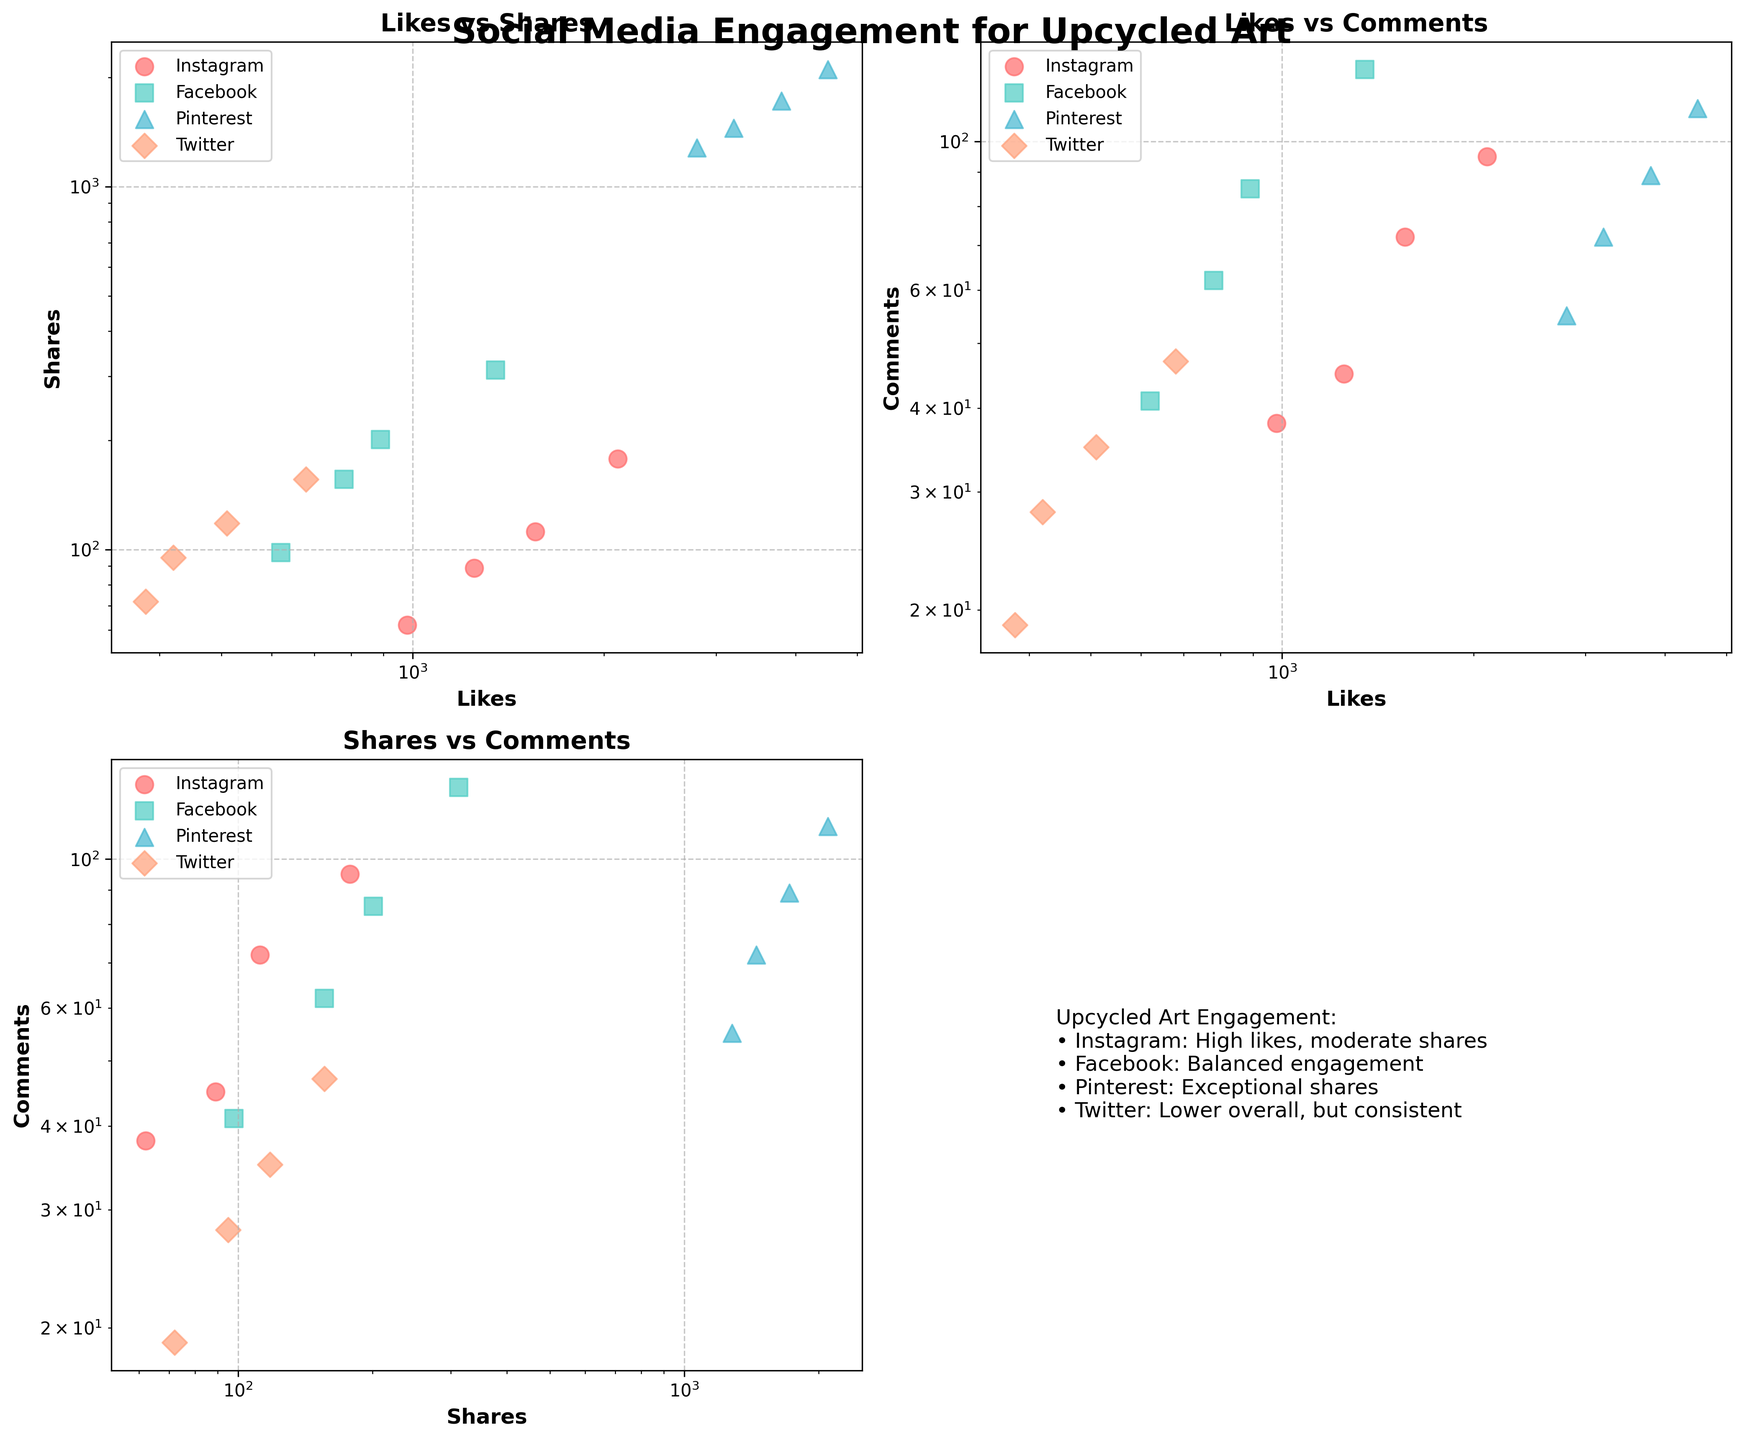What is the title of the figure? The title of the figure is displayed at the top of the plot in bold and large font. It reads "Social Media Engagement for Upcycled Art".
Answer: Social Media Engagement for Upcycled Art Which platform shows the highest number of shares? To determine the highest number of shares, look for the data points with the highest values on the y-axis for the 'Likes vs Shares' subplot. Pinterest has the highest shares, reaching above 2000 with Eco-Friendly Sculptures.
Answer: Pinterest How do the likes for Instagram posts of Upcycled Furniture compare to Facebook posts of the same type? Compare the data points for Upcycled Furniture on Instagram and Facebook in the 'Likes vs Shares' subplot by observing the x-axis values. Instagram has 1250 likes, while Facebook has 780 likes.
Answer: Instagram has more likes Which platform shows the most balanced engagement in terms of likes and shares? Identify the platform with data points that are more evenly distributed around a 45-degree line in the 'Likes vs Shares' subplot, indicating similar values for likes and shares. Facebook is the most balanced.
Answer: Facebook How do shares of Pinterest posts of Repurposed Textiles compare to Twitter posts of the same type? Locate the data points for Repurposed Textiles in the 'Likes vs Shares' subplot. Pinterest shows a significantly higher number of shares (around 1720) compared to Twitter (118).
Answer: Pinterest has more shares Are there more comments on Eco-Friendly Sculptures posts on Instagram or Facebook? Evaluate the data points in the 'Likes vs Comments' subplot. Instagram has 95 comments on Eco-Friendly Sculptures, whereas Facebook has 128 comments.
Answer: Facebook Which platform has the least engagement in terms of likes and comments? Check for the lowest data points in both the 'Likes vs Shares' and 'Likes vs Comments' subplots. Twitter consistently shows the lowest engagement in both metrics.
Answer: Twitter Which type of post on Instagram has the highest engagement in terms of shares? Assess the 'Likes vs Shares' subplot for Instagram data points. Eco-Friendly Sculptures have the highest number of shares on Instagram, around 178.
Answer: Eco-Friendly Sculptures By how much do shares of Pinterest posts of Eco-Friendly Sculptures exceed those of Instagram posts of Repurposed Textiles? Look at the y-axis values in the 'Likes vs Shares' subplot. Pinterest Eco-Friendly Sculptures shares are about 2100, Instagram Repurposed Textiles shares are about 112. The difference is 2100 - 112 = 1988.
Answer: 1988 Which platform is noted for exceptional shares in the text box in the fourth subplot? The text box in the fourth subplot mentions detailed engagement information for different platforms. According to the text, Pinterest is noted for exceptional shares.
Answer: Pinterest How do the comments on Facebook posts of Upcycled Furniture compare to Twitter posts of the same type? Compare the y-axis values for Upcycled Furniture in the 'Likes vs Comments' subplot. Facebook has 62 comments, while Twitter has 28 comments.
Answer: Facebook has more comments 